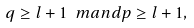Convert formula to latex. <formula><loc_0><loc_0><loc_500><loc_500>q \geq l + 1 \ m a n d p \geq l + 1 ,</formula> 